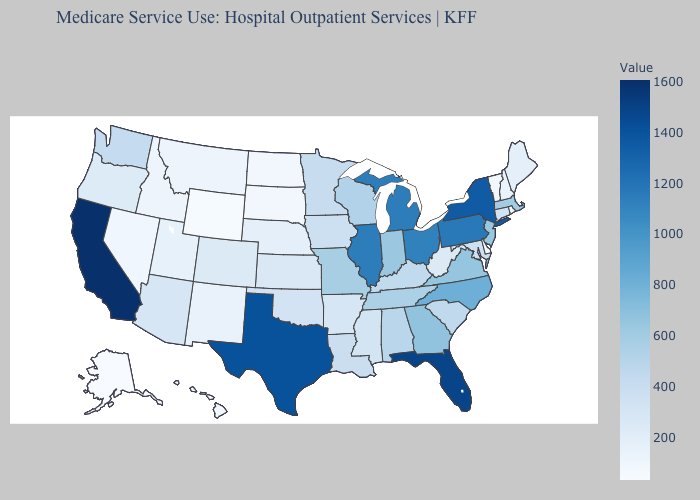Does North Dakota have the lowest value in the MidWest?
Quick response, please. Yes. Does Iowa have the lowest value in the USA?
Concise answer only. No. Does Wisconsin have a lower value than Utah?
Quick response, please. No. Among the states that border New Hampshire , does Vermont have the highest value?
Be succinct. No. Among the states that border North Carolina , which have the lowest value?
Quick response, please. South Carolina. Does Oregon have the lowest value in the USA?
Quick response, please. No. Which states have the lowest value in the USA?
Write a very short answer. Alaska. 